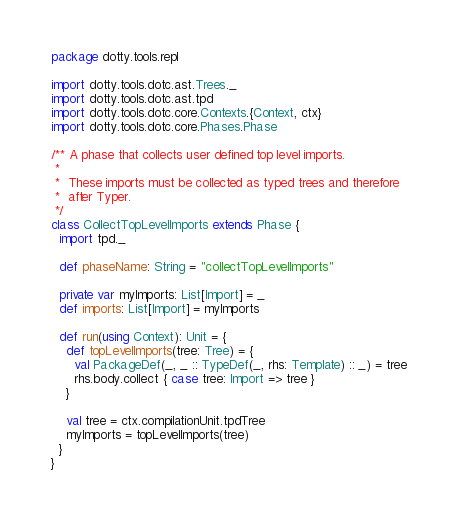Convert code to text. <code><loc_0><loc_0><loc_500><loc_500><_Scala_>package dotty.tools.repl

import dotty.tools.dotc.ast.Trees._
import dotty.tools.dotc.ast.tpd
import dotty.tools.dotc.core.Contexts.{Context, ctx}
import dotty.tools.dotc.core.Phases.Phase

/** A phase that collects user defined top level imports.
 *
 *  These imports must be collected as typed trees and therefore
 *  after Typer.
 */
class CollectTopLevelImports extends Phase {
  import tpd._

  def phaseName: String = "collectTopLevelImports"

  private var myImports: List[Import] = _
  def imports: List[Import] = myImports

  def run(using Context): Unit = {
    def topLevelImports(tree: Tree) = {
      val PackageDef(_, _ :: TypeDef(_, rhs: Template) :: _) = tree
      rhs.body.collect { case tree: Import => tree }
    }

    val tree = ctx.compilationUnit.tpdTree
    myImports = topLevelImports(tree)
  }
}
</code> 